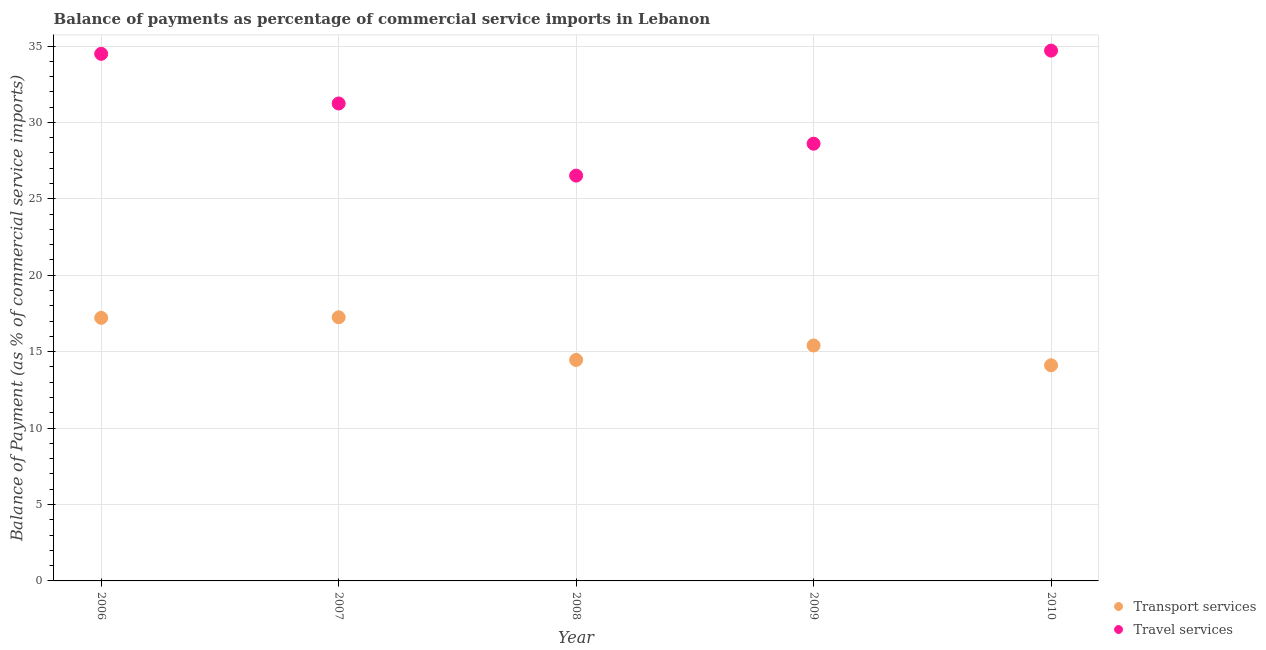How many different coloured dotlines are there?
Keep it short and to the point. 2. Is the number of dotlines equal to the number of legend labels?
Provide a succinct answer. Yes. What is the balance of payments of transport services in 2007?
Your answer should be very brief. 17.25. Across all years, what is the maximum balance of payments of transport services?
Offer a terse response. 17.25. Across all years, what is the minimum balance of payments of travel services?
Make the answer very short. 26.52. In which year was the balance of payments of travel services maximum?
Offer a very short reply. 2010. What is the total balance of payments of travel services in the graph?
Your answer should be compact. 155.56. What is the difference between the balance of payments of transport services in 2006 and that in 2010?
Ensure brevity in your answer.  3.1. What is the difference between the balance of payments of transport services in 2006 and the balance of payments of travel services in 2009?
Ensure brevity in your answer.  -11.39. What is the average balance of payments of transport services per year?
Your response must be concise. 15.69. In the year 2010, what is the difference between the balance of payments of transport services and balance of payments of travel services?
Make the answer very short. -20.59. What is the ratio of the balance of payments of travel services in 2007 to that in 2009?
Offer a very short reply. 1.09. Is the balance of payments of transport services in 2006 less than that in 2010?
Provide a succinct answer. No. What is the difference between the highest and the second highest balance of payments of transport services?
Provide a succinct answer. 0.04. What is the difference between the highest and the lowest balance of payments of transport services?
Provide a short and direct response. 3.14. Does the balance of payments of transport services monotonically increase over the years?
Ensure brevity in your answer.  No. Is the balance of payments of travel services strictly greater than the balance of payments of transport services over the years?
Ensure brevity in your answer.  Yes. Is the balance of payments of transport services strictly less than the balance of payments of travel services over the years?
Your answer should be compact. Yes. How many dotlines are there?
Your answer should be compact. 2. How many years are there in the graph?
Make the answer very short. 5. What is the difference between two consecutive major ticks on the Y-axis?
Keep it short and to the point. 5. Where does the legend appear in the graph?
Offer a very short reply. Bottom right. What is the title of the graph?
Ensure brevity in your answer.  Balance of payments as percentage of commercial service imports in Lebanon. What is the label or title of the X-axis?
Provide a succinct answer. Year. What is the label or title of the Y-axis?
Keep it short and to the point. Balance of Payment (as % of commercial service imports). What is the Balance of Payment (as % of commercial service imports) in Transport services in 2006?
Your answer should be very brief. 17.21. What is the Balance of Payment (as % of commercial service imports) of Travel services in 2006?
Provide a short and direct response. 34.49. What is the Balance of Payment (as % of commercial service imports) in Transport services in 2007?
Your answer should be compact. 17.25. What is the Balance of Payment (as % of commercial service imports) in Travel services in 2007?
Provide a succinct answer. 31.24. What is the Balance of Payment (as % of commercial service imports) in Transport services in 2008?
Keep it short and to the point. 14.46. What is the Balance of Payment (as % of commercial service imports) of Travel services in 2008?
Your answer should be compact. 26.52. What is the Balance of Payment (as % of commercial service imports) of Transport services in 2009?
Your response must be concise. 15.41. What is the Balance of Payment (as % of commercial service imports) of Travel services in 2009?
Your answer should be compact. 28.61. What is the Balance of Payment (as % of commercial service imports) of Transport services in 2010?
Your response must be concise. 14.11. What is the Balance of Payment (as % of commercial service imports) in Travel services in 2010?
Give a very brief answer. 34.7. Across all years, what is the maximum Balance of Payment (as % of commercial service imports) of Transport services?
Give a very brief answer. 17.25. Across all years, what is the maximum Balance of Payment (as % of commercial service imports) of Travel services?
Offer a terse response. 34.7. Across all years, what is the minimum Balance of Payment (as % of commercial service imports) of Transport services?
Your response must be concise. 14.11. Across all years, what is the minimum Balance of Payment (as % of commercial service imports) in Travel services?
Give a very brief answer. 26.52. What is the total Balance of Payment (as % of commercial service imports) in Transport services in the graph?
Make the answer very short. 78.44. What is the total Balance of Payment (as % of commercial service imports) of Travel services in the graph?
Provide a short and direct response. 155.56. What is the difference between the Balance of Payment (as % of commercial service imports) in Transport services in 2006 and that in 2007?
Your answer should be very brief. -0.04. What is the difference between the Balance of Payment (as % of commercial service imports) in Travel services in 2006 and that in 2007?
Keep it short and to the point. 3.25. What is the difference between the Balance of Payment (as % of commercial service imports) in Transport services in 2006 and that in 2008?
Offer a very short reply. 2.75. What is the difference between the Balance of Payment (as % of commercial service imports) in Travel services in 2006 and that in 2008?
Provide a succinct answer. 7.97. What is the difference between the Balance of Payment (as % of commercial service imports) in Transport services in 2006 and that in 2009?
Make the answer very short. 1.81. What is the difference between the Balance of Payment (as % of commercial service imports) of Travel services in 2006 and that in 2009?
Provide a short and direct response. 5.88. What is the difference between the Balance of Payment (as % of commercial service imports) in Transport services in 2006 and that in 2010?
Your answer should be very brief. 3.1. What is the difference between the Balance of Payment (as % of commercial service imports) in Travel services in 2006 and that in 2010?
Keep it short and to the point. -0.21. What is the difference between the Balance of Payment (as % of commercial service imports) in Transport services in 2007 and that in 2008?
Provide a short and direct response. 2.79. What is the difference between the Balance of Payment (as % of commercial service imports) of Travel services in 2007 and that in 2008?
Give a very brief answer. 4.72. What is the difference between the Balance of Payment (as % of commercial service imports) in Transport services in 2007 and that in 2009?
Give a very brief answer. 1.84. What is the difference between the Balance of Payment (as % of commercial service imports) in Travel services in 2007 and that in 2009?
Provide a succinct answer. 2.63. What is the difference between the Balance of Payment (as % of commercial service imports) of Transport services in 2007 and that in 2010?
Give a very brief answer. 3.14. What is the difference between the Balance of Payment (as % of commercial service imports) in Travel services in 2007 and that in 2010?
Your answer should be very brief. -3.46. What is the difference between the Balance of Payment (as % of commercial service imports) in Transport services in 2008 and that in 2009?
Your answer should be compact. -0.95. What is the difference between the Balance of Payment (as % of commercial service imports) of Travel services in 2008 and that in 2009?
Provide a succinct answer. -2.09. What is the difference between the Balance of Payment (as % of commercial service imports) in Transport services in 2008 and that in 2010?
Your answer should be compact. 0.35. What is the difference between the Balance of Payment (as % of commercial service imports) in Travel services in 2008 and that in 2010?
Keep it short and to the point. -8.18. What is the difference between the Balance of Payment (as % of commercial service imports) in Transport services in 2009 and that in 2010?
Your answer should be very brief. 1.3. What is the difference between the Balance of Payment (as % of commercial service imports) of Travel services in 2009 and that in 2010?
Keep it short and to the point. -6.09. What is the difference between the Balance of Payment (as % of commercial service imports) of Transport services in 2006 and the Balance of Payment (as % of commercial service imports) of Travel services in 2007?
Provide a succinct answer. -14.03. What is the difference between the Balance of Payment (as % of commercial service imports) in Transport services in 2006 and the Balance of Payment (as % of commercial service imports) in Travel services in 2008?
Provide a short and direct response. -9.31. What is the difference between the Balance of Payment (as % of commercial service imports) in Transport services in 2006 and the Balance of Payment (as % of commercial service imports) in Travel services in 2009?
Offer a terse response. -11.39. What is the difference between the Balance of Payment (as % of commercial service imports) of Transport services in 2006 and the Balance of Payment (as % of commercial service imports) of Travel services in 2010?
Make the answer very short. -17.49. What is the difference between the Balance of Payment (as % of commercial service imports) of Transport services in 2007 and the Balance of Payment (as % of commercial service imports) of Travel services in 2008?
Offer a very short reply. -9.27. What is the difference between the Balance of Payment (as % of commercial service imports) in Transport services in 2007 and the Balance of Payment (as % of commercial service imports) in Travel services in 2009?
Your answer should be compact. -11.36. What is the difference between the Balance of Payment (as % of commercial service imports) of Transport services in 2007 and the Balance of Payment (as % of commercial service imports) of Travel services in 2010?
Your response must be concise. -17.45. What is the difference between the Balance of Payment (as % of commercial service imports) of Transport services in 2008 and the Balance of Payment (as % of commercial service imports) of Travel services in 2009?
Give a very brief answer. -14.15. What is the difference between the Balance of Payment (as % of commercial service imports) in Transport services in 2008 and the Balance of Payment (as % of commercial service imports) in Travel services in 2010?
Provide a succinct answer. -20.24. What is the difference between the Balance of Payment (as % of commercial service imports) of Transport services in 2009 and the Balance of Payment (as % of commercial service imports) of Travel services in 2010?
Keep it short and to the point. -19.29. What is the average Balance of Payment (as % of commercial service imports) in Transport services per year?
Your answer should be very brief. 15.69. What is the average Balance of Payment (as % of commercial service imports) in Travel services per year?
Your response must be concise. 31.11. In the year 2006, what is the difference between the Balance of Payment (as % of commercial service imports) in Transport services and Balance of Payment (as % of commercial service imports) in Travel services?
Provide a short and direct response. -17.27. In the year 2007, what is the difference between the Balance of Payment (as % of commercial service imports) in Transport services and Balance of Payment (as % of commercial service imports) in Travel services?
Keep it short and to the point. -13.99. In the year 2008, what is the difference between the Balance of Payment (as % of commercial service imports) of Transport services and Balance of Payment (as % of commercial service imports) of Travel services?
Give a very brief answer. -12.06. In the year 2009, what is the difference between the Balance of Payment (as % of commercial service imports) of Transport services and Balance of Payment (as % of commercial service imports) of Travel services?
Provide a short and direct response. -13.2. In the year 2010, what is the difference between the Balance of Payment (as % of commercial service imports) of Transport services and Balance of Payment (as % of commercial service imports) of Travel services?
Give a very brief answer. -20.59. What is the ratio of the Balance of Payment (as % of commercial service imports) in Transport services in 2006 to that in 2007?
Make the answer very short. 1. What is the ratio of the Balance of Payment (as % of commercial service imports) in Travel services in 2006 to that in 2007?
Offer a very short reply. 1.1. What is the ratio of the Balance of Payment (as % of commercial service imports) of Transport services in 2006 to that in 2008?
Offer a terse response. 1.19. What is the ratio of the Balance of Payment (as % of commercial service imports) in Travel services in 2006 to that in 2008?
Give a very brief answer. 1.3. What is the ratio of the Balance of Payment (as % of commercial service imports) of Transport services in 2006 to that in 2009?
Provide a short and direct response. 1.12. What is the ratio of the Balance of Payment (as % of commercial service imports) of Travel services in 2006 to that in 2009?
Keep it short and to the point. 1.21. What is the ratio of the Balance of Payment (as % of commercial service imports) of Transport services in 2006 to that in 2010?
Make the answer very short. 1.22. What is the ratio of the Balance of Payment (as % of commercial service imports) of Travel services in 2006 to that in 2010?
Your answer should be compact. 0.99. What is the ratio of the Balance of Payment (as % of commercial service imports) in Transport services in 2007 to that in 2008?
Offer a terse response. 1.19. What is the ratio of the Balance of Payment (as % of commercial service imports) in Travel services in 2007 to that in 2008?
Provide a short and direct response. 1.18. What is the ratio of the Balance of Payment (as % of commercial service imports) of Transport services in 2007 to that in 2009?
Provide a succinct answer. 1.12. What is the ratio of the Balance of Payment (as % of commercial service imports) of Travel services in 2007 to that in 2009?
Your response must be concise. 1.09. What is the ratio of the Balance of Payment (as % of commercial service imports) of Transport services in 2007 to that in 2010?
Keep it short and to the point. 1.22. What is the ratio of the Balance of Payment (as % of commercial service imports) in Travel services in 2007 to that in 2010?
Your answer should be very brief. 0.9. What is the ratio of the Balance of Payment (as % of commercial service imports) in Transport services in 2008 to that in 2009?
Make the answer very short. 0.94. What is the ratio of the Balance of Payment (as % of commercial service imports) in Travel services in 2008 to that in 2009?
Your answer should be compact. 0.93. What is the ratio of the Balance of Payment (as % of commercial service imports) of Transport services in 2008 to that in 2010?
Ensure brevity in your answer.  1.02. What is the ratio of the Balance of Payment (as % of commercial service imports) in Travel services in 2008 to that in 2010?
Give a very brief answer. 0.76. What is the ratio of the Balance of Payment (as % of commercial service imports) in Transport services in 2009 to that in 2010?
Provide a short and direct response. 1.09. What is the ratio of the Balance of Payment (as % of commercial service imports) of Travel services in 2009 to that in 2010?
Provide a short and direct response. 0.82. What is the difference between the highest and the second highest Balance of Payment (as % of commercial service imports) in Transport services?
Your answer should be compact. 0.04. What is the difference between the highest and the second highest Balance of Payment (as % of commercial service imports) of Travel services?
Provide a succinct answer. 0.21. What is the difference between the highest and the lowest Balance of Payment (as % of commercial service imports) of Transport services?
Keep it short and to the point. 3.14. What is the difference between the highest and the lowest Balance of Payment (as % of commercial service imports) of Travel services?
Your answer should be very brief. 8.18. 